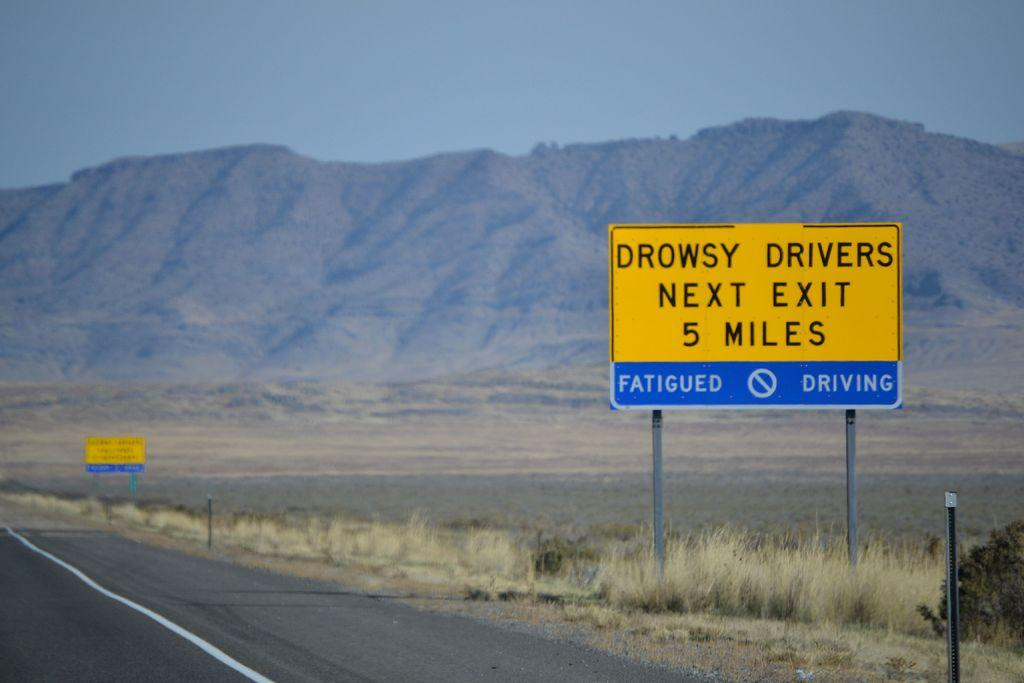<image>
Provide a brief description of the given image. a yellow sign that has the word drowsy on it 